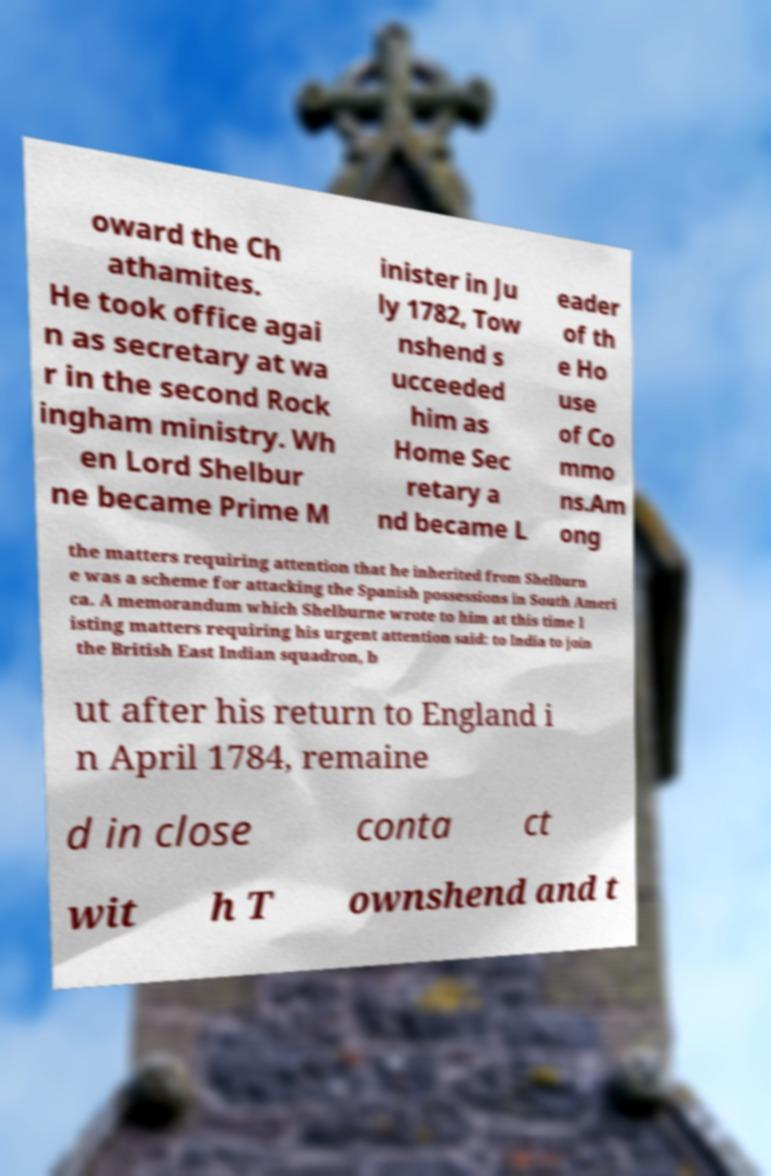Could you assist in decoding the text presented in this image and type it out clearly? oward the Ch athamites. He took office agai n as secretary at wa r in the second Rock ingham ministry. Wh en Lord Shelbur ne became Prime M inister in Ju ly 1782, Tow nshend s ucceeded him as Home Sec retary a nd became L eader of th e Ho use of Co mmo ns.Am ong the matters requiring attention that he inherited from Shelburn e was a scheme for attacking the Spanish possessions in South Ameri ca. A memorandum which Shelburne wrote to him at this time l isting matters requiring his urgent attention said: to India to join the British East Indian squadron, b ut after his return to England i n April 1784, remaine d in close conta ct wit h T ownshend and t 